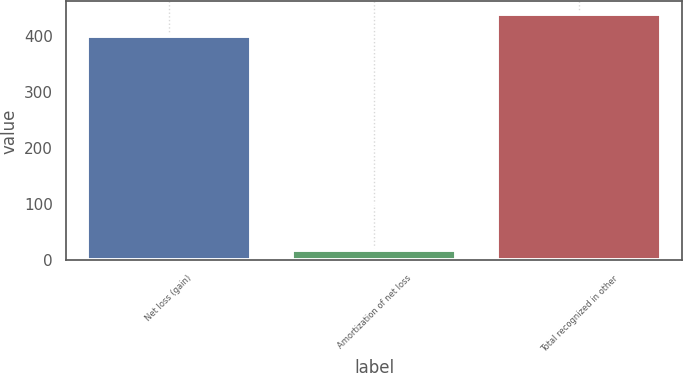Convert chart. <chart><loc_0><loc_0><loc_500><loc_500><bar_chart><fcel>Net loss (gain)<fcel>Amortization of net loss<fcel>Total recognized in other<nl><fcel>401<fcel>18<fcel>440.9<nl></chart> 